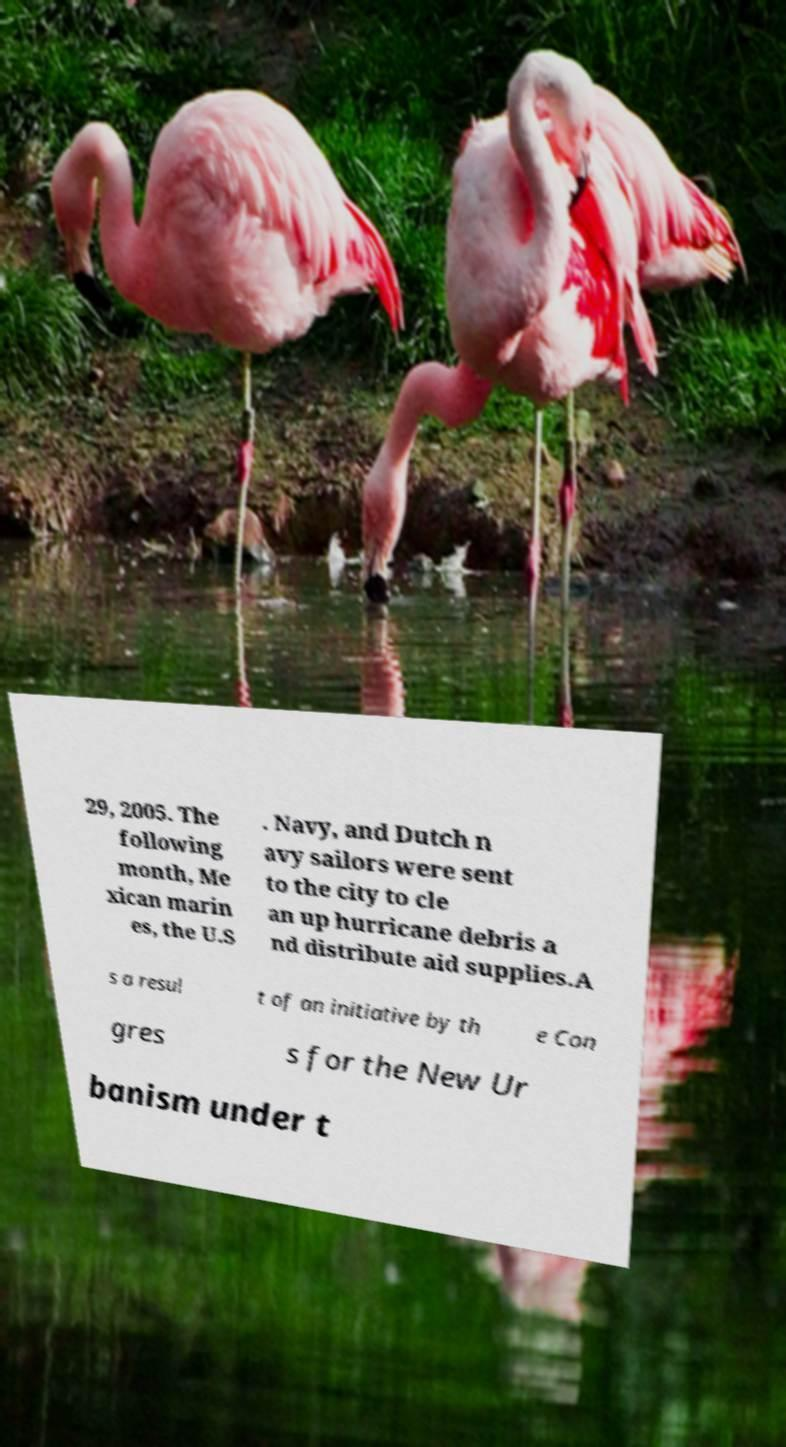Could you extract and type out the text from this image? 29, 2005. The following month, Me xican marin es, the U.S . Navy, and Dutch n avy sailors were sent to the city to cle an up hurricane debris a nd distribute aid supplies.A s a resul t of an initiative by th e Con gres s for the New Ur banism under t 